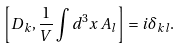<formula> <loc_0><loc_0><loc_500><loc_500>\left [ D _ { k } , \frac { 1 } { V } \int d ^ { 3 } x \, A _ { l } \right ] = i \delta _ { k l } .</formula> 